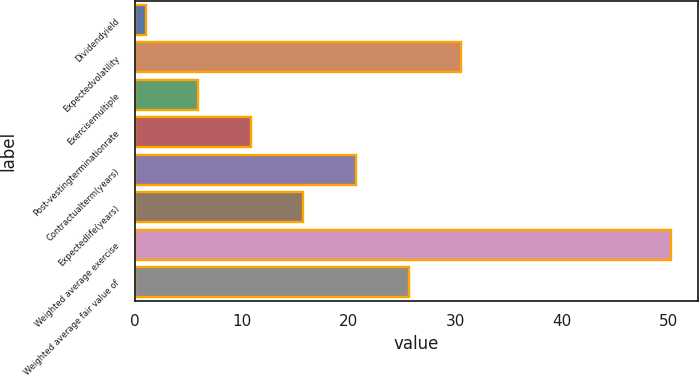Convert chart to OTSL. <chart><loc_0><loc_0><loc_500><loc_500><bar_chart><fcel>Dividendyield<fcel>Expectedvolatility<fcel>Exercisemultiple<fcel>Post-vestingterminationrate<fcel>Contractualterm(years)<fcel>Expectedlife(years)<fcel>Weighted average exercise<fcel>Weighted average fair value of<nl><fcel>1.04<fcel>30.56<fcel>5.96<fcel>10.88<fcel>20.72<fcel>15.8<fcel>50.21<fcel>25.64<nl></chart> 